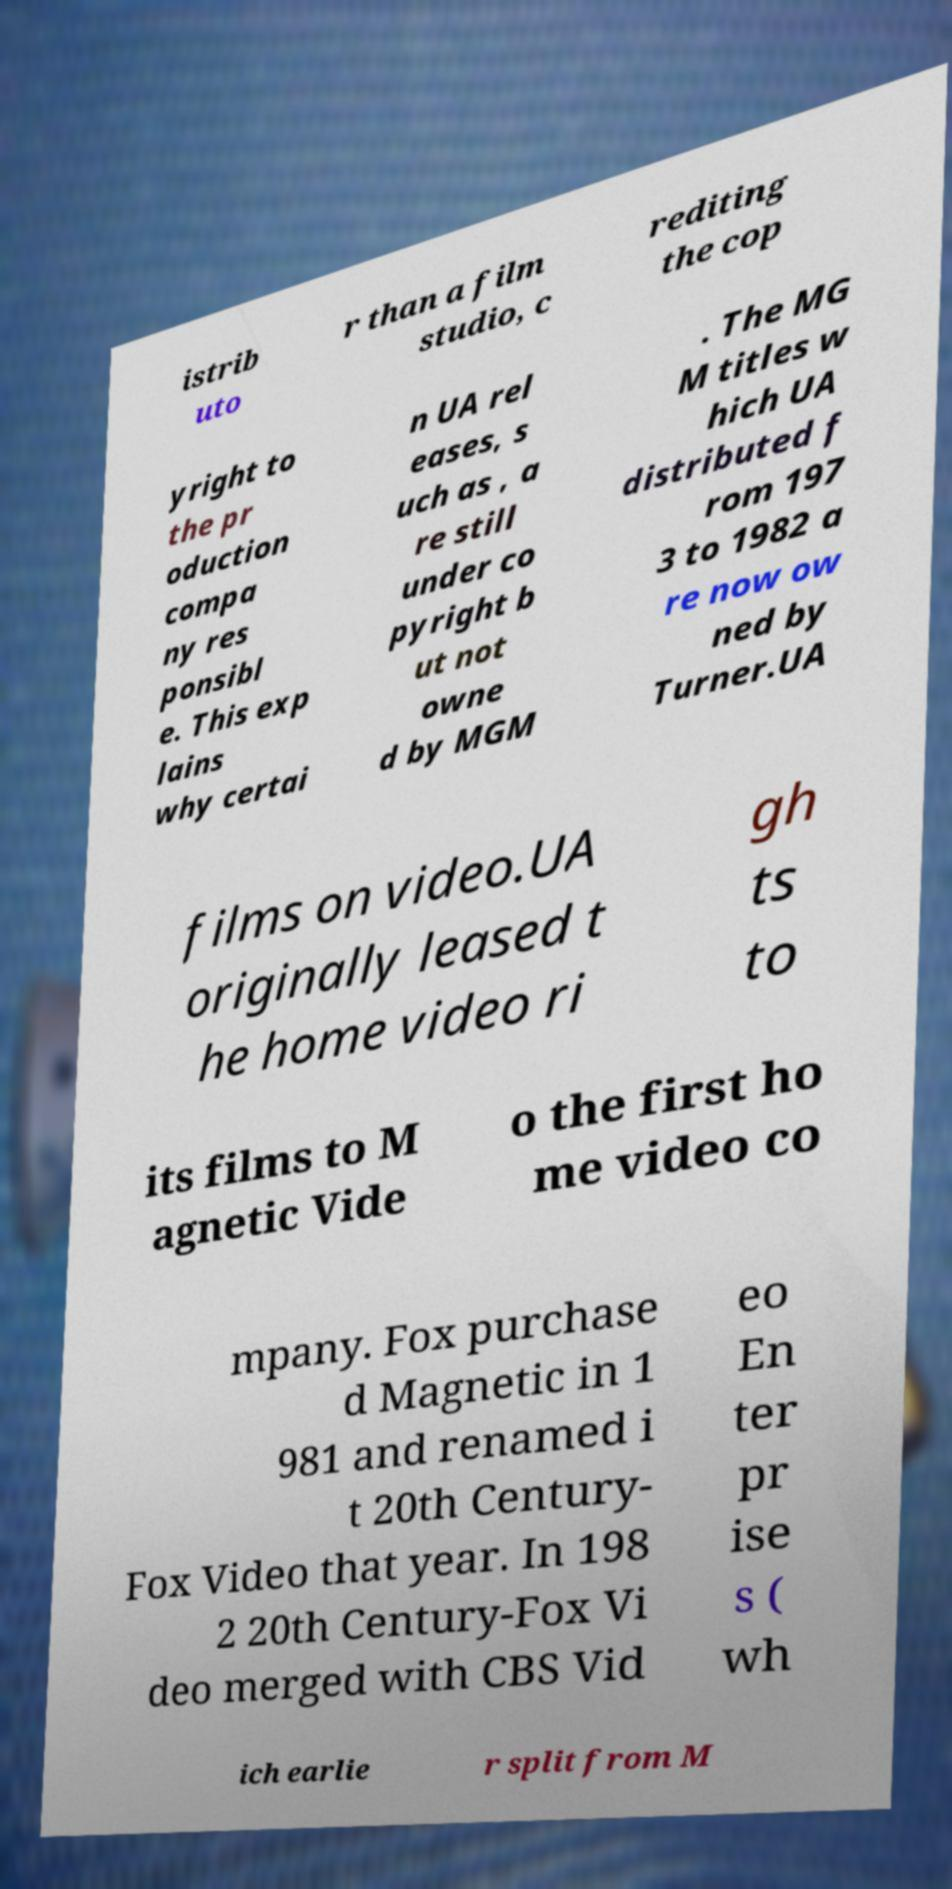There's text embedded in this image that I need extracted. Can you transcribe it verbatim? istrib uto r than a film studio, c rediting the cop yright to the pr oduction compa ny res ponsibl e. This exp lains why certai n UA rel eases, s uch as , a re still under co pyright b ut not owne d by MGM . The MG M titles w hich UA distributed f rom 197 3 to 1982 a re now ow ned by Turner.UA films on video.UA originally leased t he home video ri gh ts to its films to M agnetic Vide o the first ho me video co mpany. Fox purchase d Magnetic in 1 981 and renamed i t 20th Century- Fox Video that year. In 198 2 20th Century-Fox Vi deo merged with CBS Vid eo En ter pr ise s ( wh ich earlie r split from M 